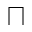<formula> <loc_0><loc_0><loc_500><loc_500>\sqcap</formula> 